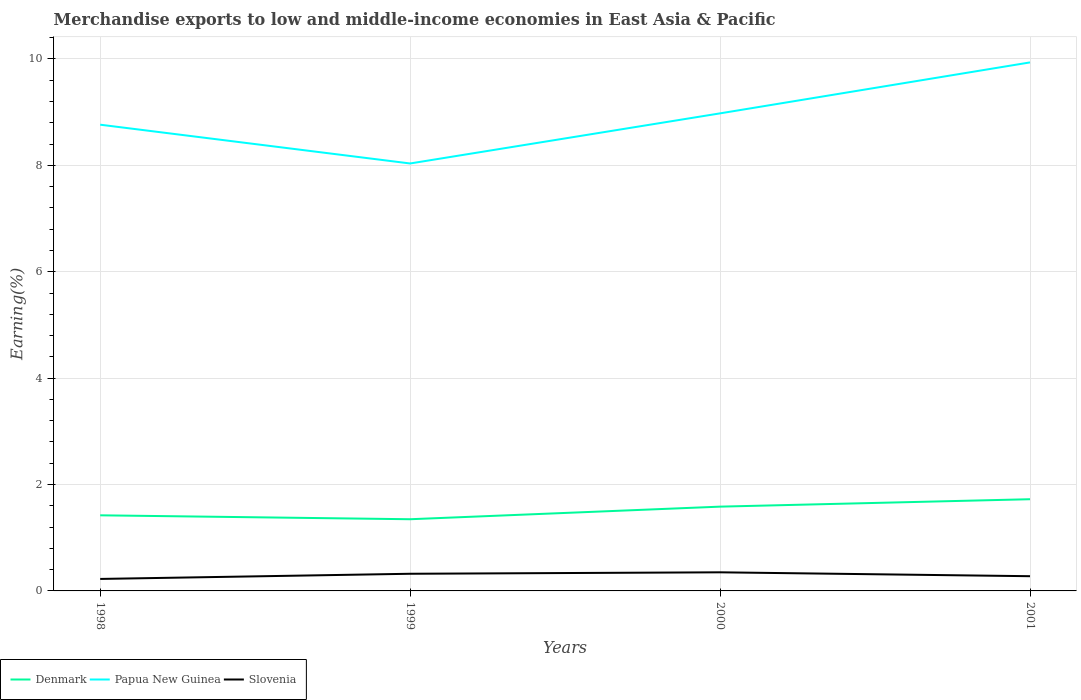Does the line corresponding to Denmark intersect with the line corresponding to Slovenia?
Your answer should be compact. No. Across all years, what is the maximum percentage of amount earned from merchandise exports in Papua New Guinea?
Offer a very short reply. 8.04. What is the total percentage of amount earned from merchandise exports in Papua New Guinea in the graph?
Your answer should be compact. -1.17. What is the difference between the highest and the second highest percentage of amount earned from merchandise exports in Papua New Guinea?
Keep it short and to the point. 1.9. Is the percentage of amount earned from merchandise exports in Denmark strictly greater than the percentage of amount earned from merchandise exports in Slovenia over the years?
Your response must be concise. No. How many years are there in the graph?
Provide a succinct answer. 4. Does the graph contain grids?
Ensure brevity in your answer.  Yes. How many legend labels are there?
Ensure brevity in your answer.  3. How are the legend labels stacked?
Ensure brevity in your answer.  Horizontal. What is the title of the graph?
Your answer should be compact. Merchandise exports to low and middle-income economies in East Asia & Pacific. Does "Thailand" appear as one of the legend labels in the graph?
Make the answer very short. No. What is the label or title of the Y-axis?
Give a very brief answer. Earning(%). What is the Earning(%) of Denmark in 1998?
Your response must be concise. 1.42. What is the Earning(%) of Papua New Guinea in 1998?
Ensure brevity in your answer.  8.76. What is the Earning(%) of Slovenia in 1998?
Offer a terse response. 0.23. What is the Earning(%) in Denmark in 1999?
Offer a terse response. 1.35. What is the Earning(%) in Papua New Guinea in 1999?
Provide a succinct answer. 8.04. What is the Earning(%) in Slovenia in 1999?
Make the answer very short. 0.32. What is the Earning(%) of Denmark in 2000?
Ensure brevity in your answer.  1.58. What is the Earning(%) in Papua New Guinea in 2000?
Give a very brief answer. 8.98. What is the Earning(%) in Slovenia in 2000?
Your answer should be compact. 0.35. What is the Earning(%) of Denmark in 2001?
Make the answer very short. 1.72. What is the Earning(%) in Papua New Guinea in 2001?
Offer a very short reply. 9.94. What is the Earning(%) in Slovenia in 2001?
Keep it short and to the point. 0.28. Across all years, what is the maximum Earning(%) of Denmark?
Offer a very short reply. 1.72. Across all years, what is the maximum Earning(%) of Papua New Guinea?
Provide a short and direct response. 9.94. Across all years, what is the maximum Earning(%) in Slovenia?
Offer a very short reply. 0.35. Across all years, what is the minimum Earning(%) of Denmark?
Provide a short and direct response. 1.35. Across all years, what is the minimum Earning(%) in Papua New Guinea?
Offer a terse response. 8.04. Across all years, what is the minimum Earning(%) of Slovenia?
Give a very brief answer. 0.23. What is the total Earning(%) of Denmark in the graph?
Provide a succinct answer. 6.08. What is the total Earning(%) of Papua New Guinea in the graph?
Your response must be concise. 35.71. What is the total Earning(%) in Slovenia in the graph?
Your answer should be compact. 1.17. What is the difference between the Earning(%) in Denmark in 1998 and that in 1999?
Ensure brevity in your answer.  0.07. What is the difference between the Earning(%) of Papua New Guinea in 1998 and that in 1999?
Keep it short and to the point. 0.73. What is the difference between the Earning(%) in Slovenia in 1998 and that in 1999?
Your response must be concise. -0.1. What is the difference between the Earning(%) in Denmark in 1998 and that in 2000?
Make the answer very short. -0.16. What is the difference between the Earning(%) in Papua New Guinea in 1998 and that in 2000?
Provide a short and direct response. -0.21. What is the difference between the Earning(%) of Slovenia in 1998 and that in 2000?
Your response must be concise. -0.12. What is the difference between the Earning(%) in Denmark in 1998 and that in 2001?
Keep it short and to the point. -0.3. What is the difference between the Earning(%) of Papua New Guinea in 1998 and that in 2001?
Keep it short and to the point. -1.17. What is the difference between the Earning(%) of Slovenia in 1998 and that in 2001?
Make the answer very short. -0.05. What is the difference between the Earning(%) in Denmark in 1999 and that in 2000?
Make the answer very short. -0.24. What is the difference between the Earning(%) in Papua New Guinea in 1999 and that in 2000?
Provide a short and direct response. -0.94. What is the difference between the Earning(%) in Slovenia in 1999 and that in 2000?
Make the answer very short. -0.03. What is the difference between the Earning(%) in Denmark in 1999 and that in 2001?
Provide a short and direct response. -0.38. What is the difference between the Earning(%) of Papua New Guinea in 1999 and that in 2001?
Offer a very short reply. -1.9. What is the difference between the Earning(%) in Slovenia in 1999 and that in 2001?
Your response must be concise. 0.05. What is the difference between the Earning(%) in Denmark in 2000 and that in 2001?
Provide a short and direct response. -0.14. What is the difference between the Earning(%) of Papua New Guinea in 2000 and that in 2001?
Provide a short and direct response. -0.96. What is the difference between the Earning(%) of Slovenia in 2000 and that in 2001?
Your response must be concise. 0.07. What is the difference between the Earning(%) in Denmark in 1998 and the Earning(%) in Papua New Guinea in 1999?
Provide a short and direct response. -6.61. What is the difference between the Earning(%) of Denmark in 1998 and the Earning(%) of Slovenia in 1999?
Provide a short and direct response. 1.1. What is the difference between the Earning(%) of Papua New Guinea in 1998 and the Earning(%) of Slovenia in 1999?
Offer a terse response. 8.44. What is the difference between the Earning(%) of Denmark in 1998 and the Earning(%) of Papua New Guinea in 2000?
Provide a succinct answer. -7.56. What is the difference between the Earning(%) of Denmark in 1998 and the Earning(%) of Slovenia in 2000?
Provide a succinct answer. 1.07. What is the difference between the Earning(%) in Papua New Guinea in 1998 and the Earning(%) in Slovenia in 2000?
Give a very brief answer. 8.41. What is the difference between the Earning(%) in Denmark in 1998 and the Earning(%) in Papua New Guinea in 2001?
Make the answer very short. -8.51. What is the difference between the Earning(%) of Denmark in 1998 and the Earning(%) of Slovenia in 2001?
Ensure brevity in your answer.  1.14. What is the difference between the Earning(%) of Papua New Guinea in 1998 and the Earning(%) of Slovenia in 2001?
Give a very brief answer. 8.49. What is the difference between the Earning(%) of Denmark in 1999 and the Earning(%) of Papua New Guinea in 2000?
Provide a short and direct response. -7.63. What is the difference between the Earning(%) in Papua New Guinea in 1999 and the Earning(%) in Slovenia in 2000?
Provide a short and direct response. 7.69. What is the difference between the Earning(%) of Denmark in 1999 and the Earning(%) of Papua New Guinea in 2001?
Provide a short and direct response. -8.59. What is the difference between the Earning(%) in Denmark in 1999 and the Earning(%) in Slovenia in 2001?
Offer a very short reply. 1.07. What is the difference between the Earning(%) of Papua New Guinea in 1999 and the Earning(%) of Slovenia in 2001?
Your answer should be compact. 7.76. What is the difference between the Earning(%) of Denmark in 2000 and the Earning(%) of Papua New Guinea in 2001?
Provide a succinct answer. -8.35. What is the difference between the Earning(%) in Denmark in 2000 and the Earning(%) in Slovenia in 2001?
Make the answer very short. 1.31. What is the difference between the Earning(%) in Papua New Guinea in 2000 and the Earning(%) in Slovenia in 2001?
Provide a succinct answer. 8.7. What is the average Earning(%) of Denmark per year?
Give a very brief answer. 1.52. What is the average Earning(%) of Papua New Guinea per year?
Your answer should be very brief. 8.93. What is the average Earning(%) in Slovenia per year?
Provide a short and direct response. 0.29. In the year 1998, what is the difference between the Earning(%) in Denmark and Earning(%) in Papua New Guinea?
Your answer should be compact. -7.34. In the year 1998, what is the difference between the Earning(%) in Denmark and Earning(%) in Slovenia?
Provide a succinct answer. 1.2. In the year 1998, what is the difference between the Earning(%) in Papua New Guinea and Earning(%) in Slovenia?
Offer a very short reply. 8.54. In the year 1999, what is the difference between the Earning(%) in Denmark and Earning(%) in Papua New Guinea?
Your response must be concise. -6.69. In the year 1999, what is the difference between the Earning(%) of Denmark and Earning(%) of Slovenia?
Your response must be concise. 1.02. In the year 1999, what is the difference between the Earning(%) in Papua New Guinea and Earning(%) in Slovenia?
Your answer should be compact. 7.71. In the year 2000, what is the difference between the Earning(%) in Denmark and Earning(%) in Papua New Guinea?
Keep it short and to the point. -7.39. In the year 2000, what is the difference between the Earning(%) in Denmark and Earning(%) in Slovenia?
Offer a terse response. 1.23. In the year 2000, what is the difference between the Earning(%) in Papua New Guinea and Earning(%) in Slovenia?
Provide a short and direct response. 8.63. In the year 2001, what is the difference between the Earning(%) in Denmark and Earning(%) in Papua New Guinea?
Give a very brief answer. -8.21. In the year 2001, what is the difference between the Earning(%) in Denmark and Earning(%) in Slovenia?
Your response must be concise. 1.45. In the year 2001, what is the difference between the Earning(%) in Papua New Guinea and Earning(%) in Slovenia?
Ensure brevity in your answer.  9.66. What is the ratio of the Earning(%) in Denmark in 1998 to that in 1999?
Keep it short and to the point. 1.05. What is the ratio of the Earning(%) in Papua New Guinea in 1998 to that in 1999?
Ensure brevity in your answer.  1.09. What is the ratio of the Earning(%) of Slovenia in 1998 to that in 1999?
Offer a very short reply. 0.7. What is the ratio of the Earning(%) in Denmark in 1998 to that in 2000?
Your answer should be very brief. 0.9. What is the ratio of the Earning(%) of Papua New Guinea in 1998 to that in 2000?
Offer a very short reply. 0.98. What is the ratio of the Earning(%) in Slovenia in 1998 to that in 2000?
Your answer should be compact. 0.64. What is the ratio of the Earning(%) in Denmark in 1998 to that in 2001?
Keep it short and to the point. 0.82. What is the ratio of the Earning(%) in Papua New Guinea in 1998 to that in 2001?
Offer a terse response. 0.88. What is the ratio of the Earning(%) in Slovenia in 1998 to that in 2001?
Your answer should be compact. 0.81. What is the ratio of the Earning(%) in Denmark in 1999 to that in 2000?
Your answer should be very brief. 0.85. What is the ratio of the Earning(%) in Papua New Guinea in 1999 to that in 2000?
Provide a short and direct response. 0.9. What is the ratio of the Earning(%) of Slovenia in 1999 to that in 2000?
Your answer should be compact. 0.92. What is the ratio of the Earning(%) of Denmark in 1999 to that in 2001?
Offer a very short reply. 0.78. What is the ratio of the Earning(%) of Papua New Guinea in 1999 to that in 2001?
Ensure brevity in your answer.  0.81. What is the ratio of the Earning(%) in Slovenia in 1999 to that in 2001?
Ensure brevity in your answer.  1.17. What is the ratio of the Earning(%) in Denmark in 2000 to that in 2001?
Keep it short and to the point. 0.92. What is the ratio of the Earning(%) in Papua New Guinea in 2000 to that in 2001?
Give a very brief answer. 0.9. What is the ratio of the Earning(%) in Slovenia in 2000 to that in 2001?
Keep it short and to the point. 1.26. What is the difference between the highest and the second highest Earning(%) of Denmark?
Ensure brevity in your answer.  0.14. What is the difference between the highest and the second highest Earning(%) of Papua New Guinea?
Make the answer very short. 0.96. What is the difference between the highest and the second highest Earning(%) in Slovenia?
Your answer should be compact. 0.03. What is the difference between the highest and the lowest Earning(%) of Denmark?
Keep it short and to the point. 0.38. What is the difference between the highest and the lowest Earning(%) in Papua New Guinea?
Keep it short and to the point. 1.9. What is the difference between the highest and the lowest Earning(%) in Slovenia?
Offer a terse response. 0.12. 